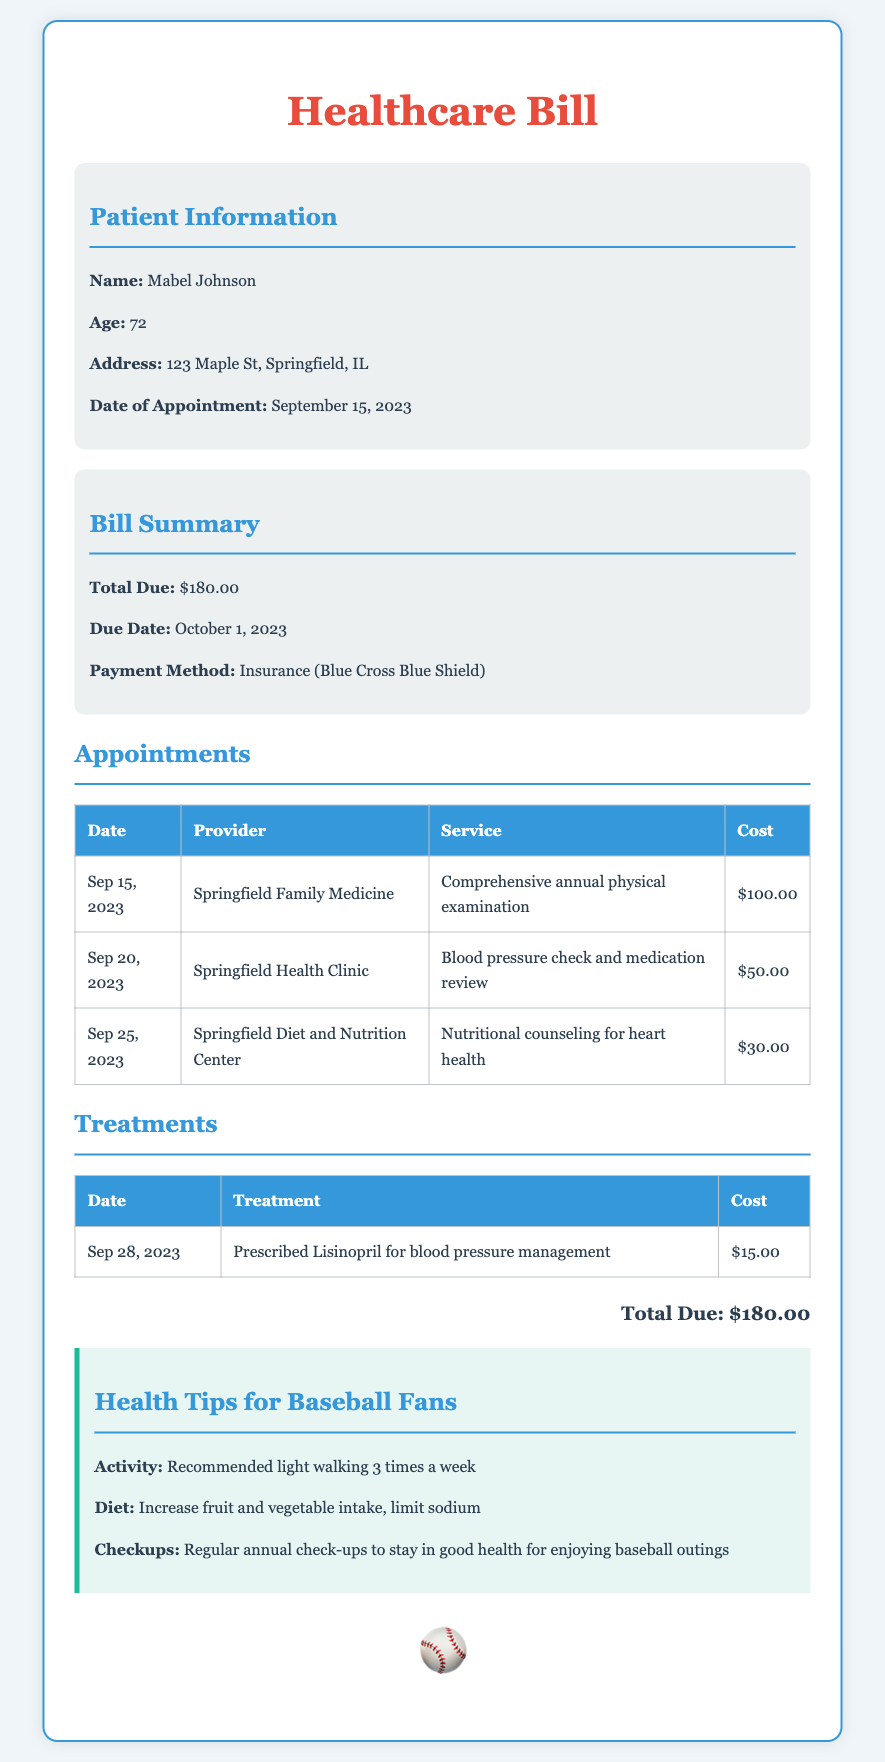What is the patient's name? The document explicitly states the name of the patient in the patient information section.
Answer: Mabel Johnson What is the date of the appointment? The date of the appointment is mentioned directly in the patient information section of the document.
Answer: September 15, 2023 What is the total due amount? The total due is clearly listed in the bill summary section.
Answer: $180.00 How much was charged for the nutritional counseling? The cost of the service can be found in the appointments table next to the specific service.
Answer: $30.00 What was prescribed for blood pressure management? The treatment details are found in the treatments table section of the document.
Answer: Lisinopril What is one recommended activity for maintaining health? The health tips section provides suggestions for staying active and healthy.
Answer: Light walking 3 times a week When is the payment due? The due date for the payment is specified in the bill summary section.
Answer: October 1, 2023 Who provided the comprehensive annual physical examination? The provider for this service is listed in the appointments table next to the service date.
Answer: Springfield Family Medicine How many appointments were listed in the document? This can be determined by counting the entries in the appointments table.
Answer: Three 